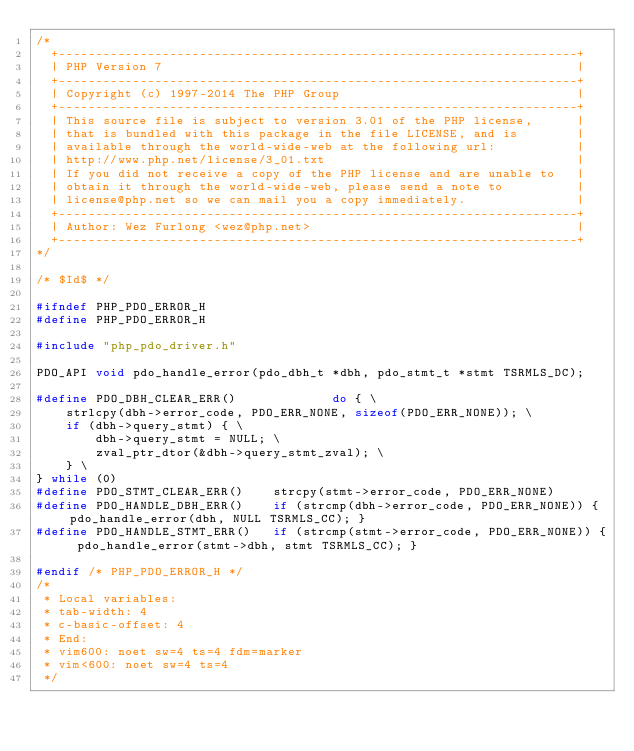<code> <loc_0><loc_0><loc_500><loc_500><_C_>/*
  +----------------------------------------------------------------------+
  | PHP Version 7                                                        |
  +----------------------------------------------------------------------+
  | Copyright (c) 1997-2014 The PHP Group                                |
  +----------------------------------------------------------------------+
  | This source file is subject to version 3.01 of the PHP license,      |
  | that is bundled with this package in the file LICENSE, and is        |
  | available through the world-wide-web at the following url:           |
  | http://www.php.net/license/3_01.txt                                  |
  | If you did not receive a copy of the PHP license and are unable to   |
  | obtain it through the world-wide-web, please send a note to          |
  | license@php.net so we can mail you a copy immediately.               |
  +----------------------------------------------------------------------+
  | Author: Wez Furlong <wez@php.net>                                    |
  +----------------------------------------------------------------------+
*/

/* $Id$ */

#ifndef PHP_PDO_ERROR_H
#define PHP_PDO_ERROR_H

#include "php_pdo_driver.h"

PDO_API void pdo_handle_error(pdo_dbh_t *dbh, pdo_stmt_t *stmt TSRMLS_DC);

#define PDO_DBH_CLEAR_ERR()             do { \
	strlcpy(dbh->error_code, PDO_ERR_NONE, sizeof(PDO_ERR_NONE)); \
	if (dbh->query_stmt) { \
		dbh->query_stmt = NULL; \
		zval_ptr_dtor(&dbh->query_stmt_zval); \
	} \
} while (0)
#define PDO_STMT_CLEAR_ERR()    strcpy(stmt->error_code, PDO_ERR_NONE)
#define PDO_HANDLE_DBH_ERR()    if (strcmp(dbh->error_code, PDO_ERR_NONE)) { pdo_handle_error(dbh, NULL TSRMLS_CC); }
#define PDO_HANDLE_STMT_ERR()   if (strcmp(stmt->error_code, PDO_ERR_NONE)) { pdo_handle_error(stmt->dbh, stmt TSRMLS_CC); }

#endif /* PHP_PDO_ERROR_H */
/*
 * Local variables:
 * tab-width: 4
 * c-basic-offset: 4
 * End:
 * vim600: noet sw=4 ts=4 fdm=marker
 * vim<600: noet sw=4 ts=4
 */
</code> 